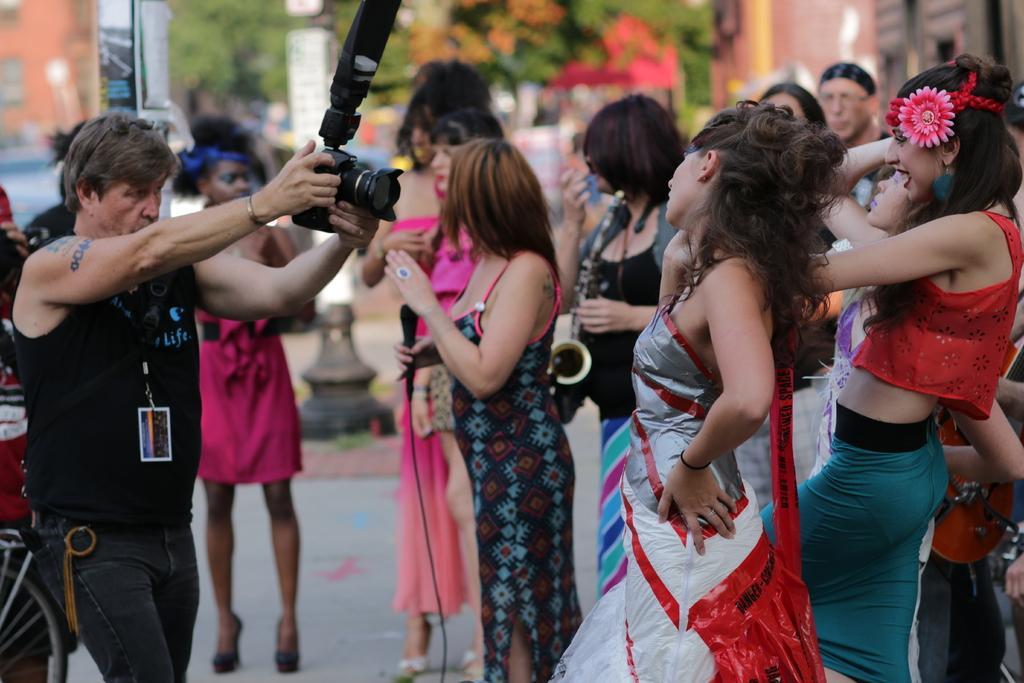Can you describe this image briefly? In this image i can see few persons standing and to the left corner of the image the person is holding a camera and capturing the people. In the background i can see trees and a building. 